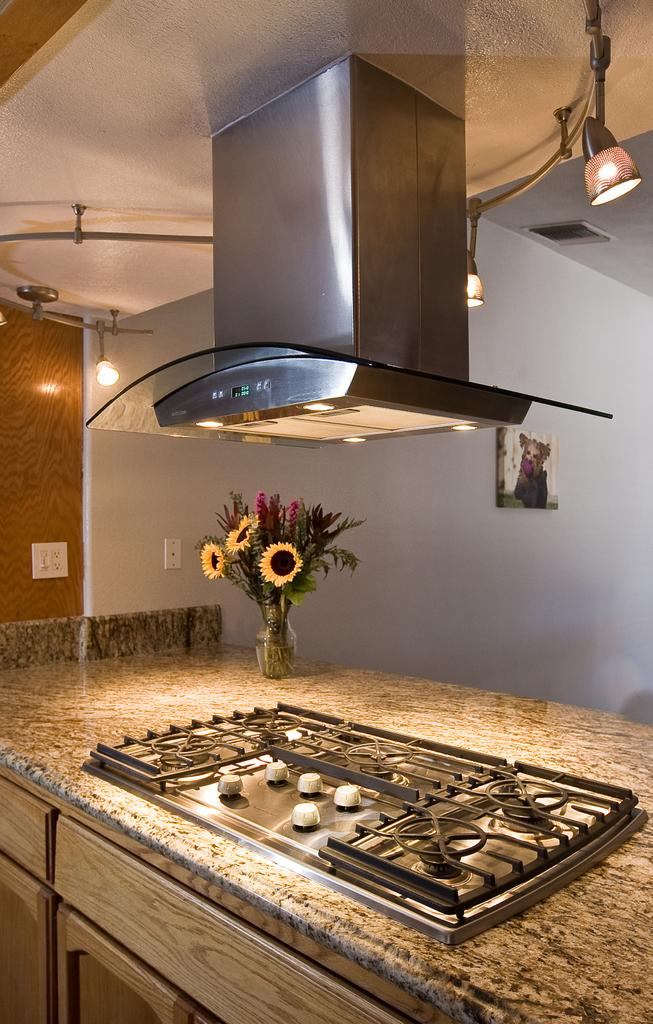What type of appliance can be seen in the image? There is a stove in the image. What type of furniture or surface is present in the image? There is a kitchen counter in the image. What type of decorative item is present in the image? There is a flower vase in the image. What type of ventilation system is present in the image? There is an air exhaust in the image. What type of lighting is present in the image? There are lights in the image. What type of wall decorations can be seen in the background of the image? In the background, there are frames attached to the wall. What type of electrical components can be seen in the background of the image? In the background, there are switch boards attached to the wall. How does the fan help to cool down the room in the image? There is no fan present in the image; it only mentions lights, frames, and switch boards. 